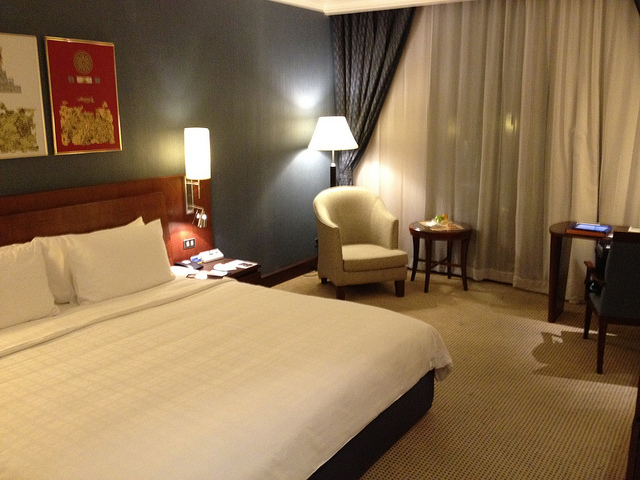Is this room suitable for working? Yes, the room includes a desk with a comfortable chair and a table lamp, providing a workspace. The surface appears ample for a laptop and documents, and there's a power outlet close by, making it conducive to work tasks. Does the room offer any form of entertainment? While the TV isn't visible in this image, the presence of a remote control on the nightstand suggests that there is likely a television in the room for guests' entertainment. 